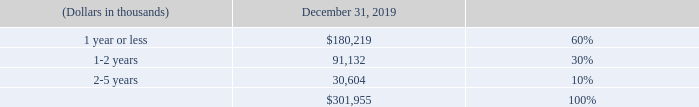Unbilled receivables are client committed amounts for which revenue recognition precedes billing, and billing is solely subject to the passage of time.
Unbilled receivables are expected to be billed in the future as follows
What does unbilled receivables refer to? Unbilled receivables are client committed amounts for which revenue recognition precedes billing. What are the respective unbilled receivables within 1 year or less and within 1-2 years?
Answer scale should be: thousand. 180,219, 91,132. What are the respective unbilled receivables within 1-2 years and within 2-5 years?
Answer scale should be: thousand. 91,132, 30,604. What is the total unbilled receivables due within 2 years?
Answer scale should be: thousand. 180,219 + 91,132 
Answer: 271351. What is the total unbilled receivables due between 1 to 5 years?
Answer scale should be: thousand. 91,132 + 30,604 
Answer: 121736. What is the value of the unbilled receivables due within 2-5 years as a percentage of the unbilled receivables due within 1 year?
Answer scale should be: percent. 30,604/180,219 
Answer: 16.98. 